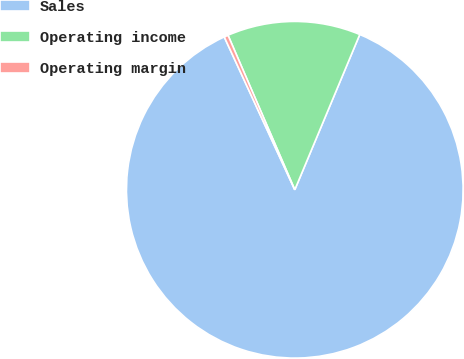Convert chart to OTSL. <chart><loc_0><loc_0><loc_500><loc_500><pie_chart><fcel>Sales<fcel>Operating income<fcel>Operating margin<nl><fcel>86.81%<fcel>12.8%<fcel>0.39%<nl></chart> 